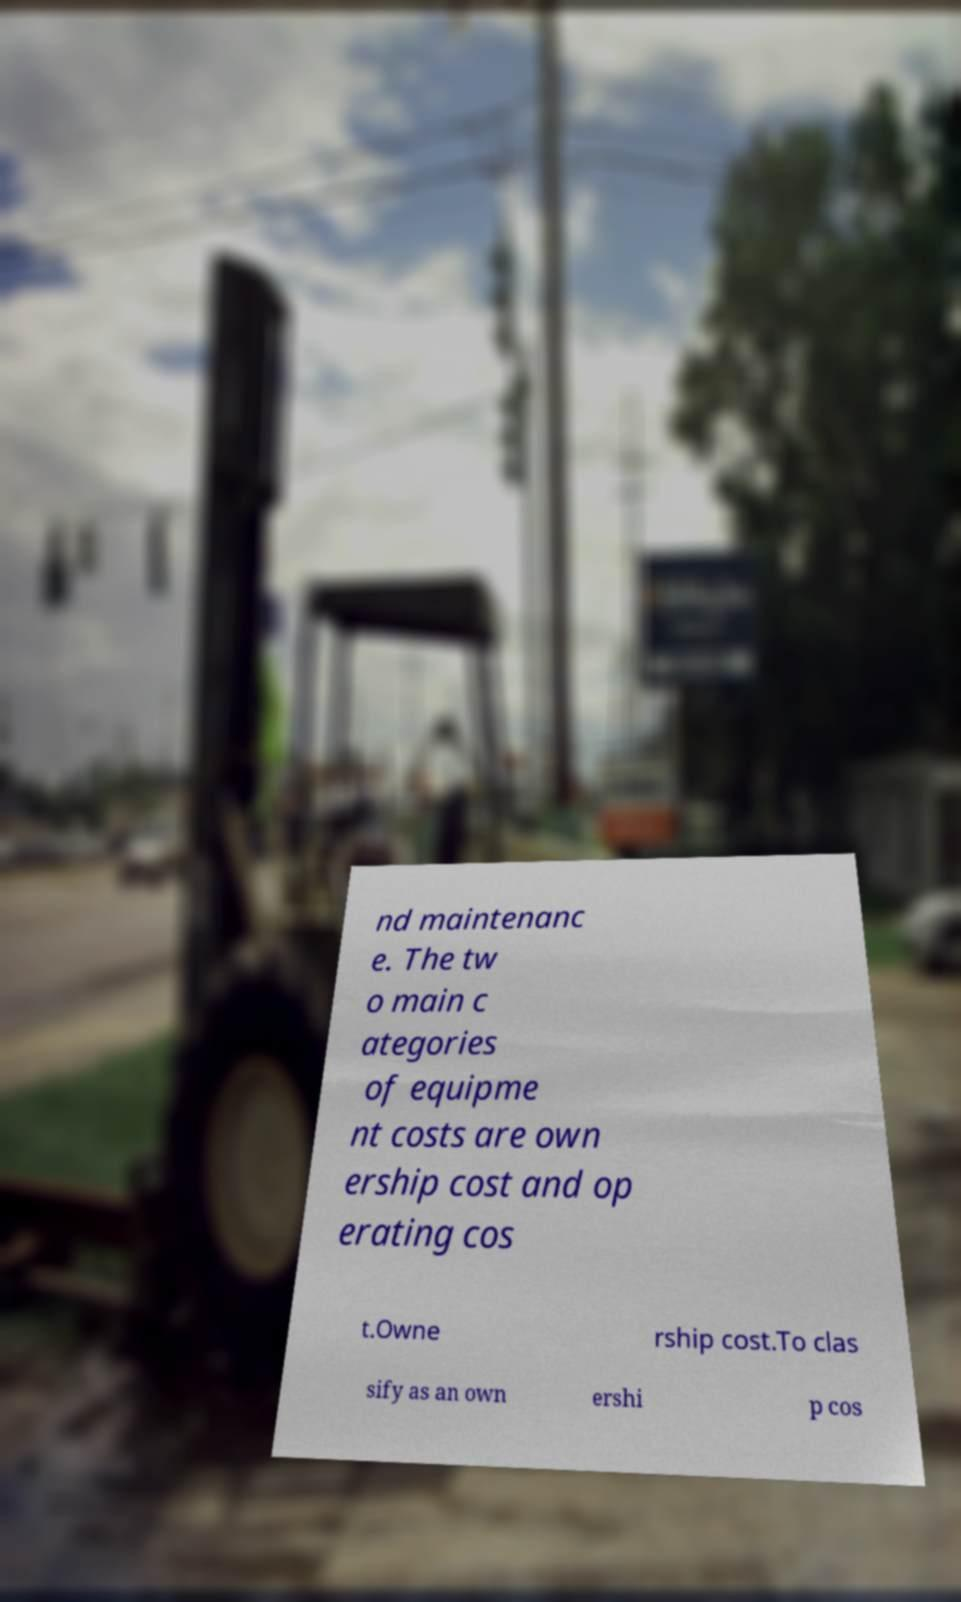Can you accurately transcribe the text from the provided image for me? nd maintenanc e. The tw o main c ategories of equipme nt costs are own ership cost and op erating cos t.Owne rship cost.To clas sify as an own ershi p cos 